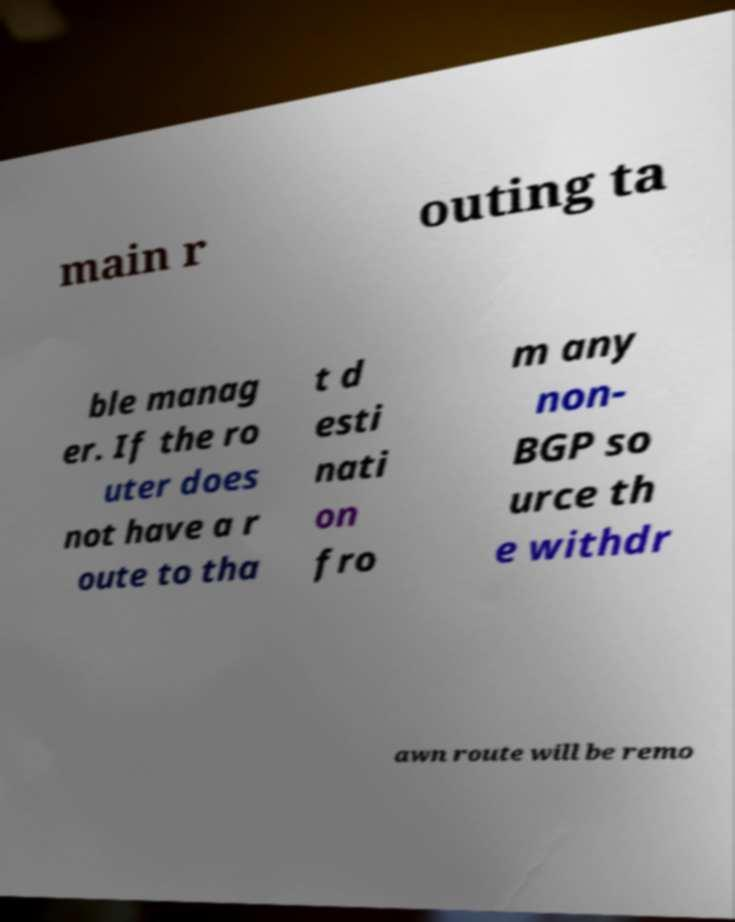Please identify and transcribe the text found in this image. main r outing ta ble manag er. If the ro uter does not have a r oute to tha t d esti nati on fro m any non- BGP so urce th e withdr awn route will be remo 